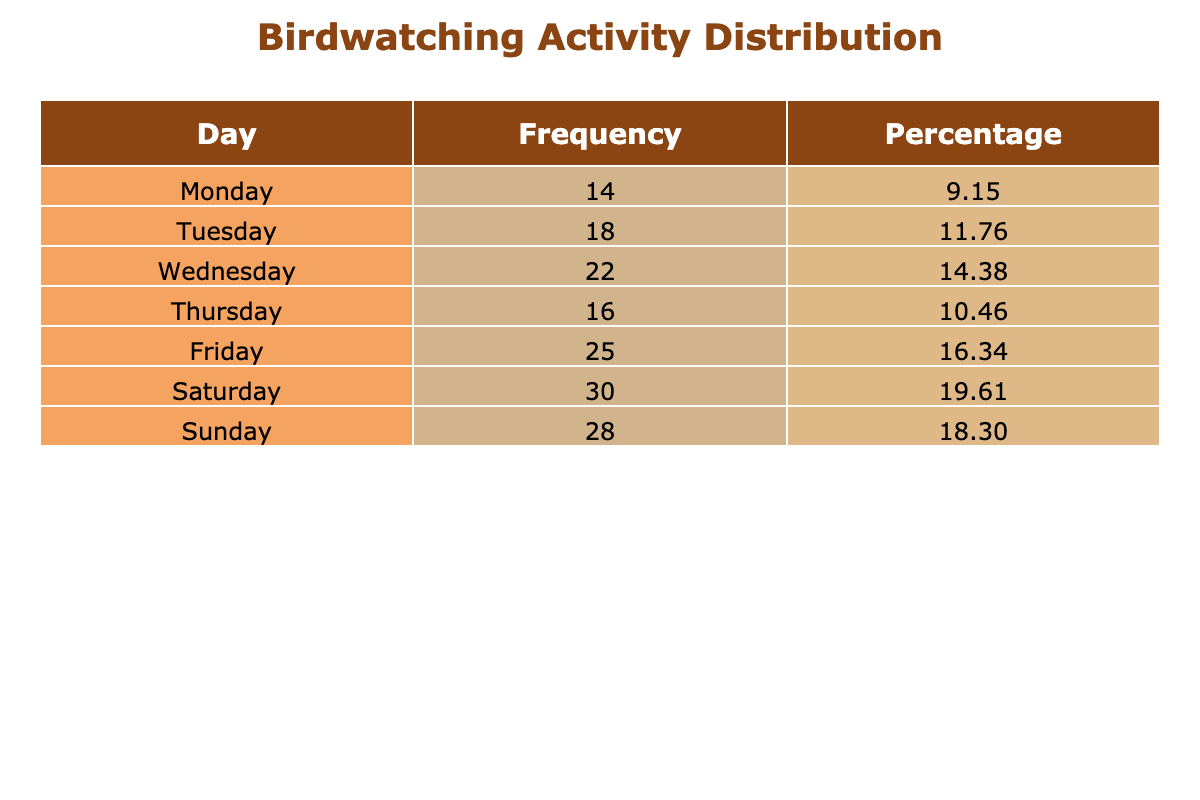What day had the highest number of birdwatching activities? According to the table, Saturday recorded the most birdwatching activities with a total of 30 instances.
Answer: Saturday How many instances of birdwatching were recorded on weekdays? The weekdays (Monday to Friday) had the following instances: 14 (Monday), 18 (Tuesday), 22 (Wednesday), 16 (Thursday), and 25 (Friday). Adding these gives 14 + 18 + 22 + 16 + 25 = 95.
Answer: 95 What is the percentage of birdwatching activities recorded on Sunday? The total number of instances is 14 + 18 + 22 + 16 + 25 + 30 + 28 = 153. For Sunday, there are 28 instances. The percentage is calculated by (28 / 153) * 100, which is approximately 18.18%.
Answer: 18.18 Is it true that more birdwatching activities occurred on the weekend than on weekdays? Weekends (Saturday and Sunday) had 30 (Saturday) + 28 (Sunday) = 58 instances, while weekdays had 95 instances. Therefore, it is not true that more activities occurred on weekends.
Answer: No What is the total difference in birdwatching activities between Friday and Monday? Friday had 25 instances while Monday had 14 instances. The difference is calculated as 25 - 14 = 11.
Answer: 11 Which day had the lowest number of instances, and how many were recorded? The table shows that Monday had the lowest number of instances with a total of 14 recorded activities.
Answer: Monday, 14 What is the average number of birdwatching instances recorded on weekdays? To find the average, sum the instances for weekdays: 14 + 18 + 22 + 16 + 25 = 95, then divide by 5 (the number of weekdays), giving 95 / 5 = 19.
Answer: 19 If we combine Tuesday and Thursday's instances, what is the total? Tuesday had 18 instances and Thursday had 16 instances. Adding these gives a total of 18 + 16 = 34.
Answer: 34 